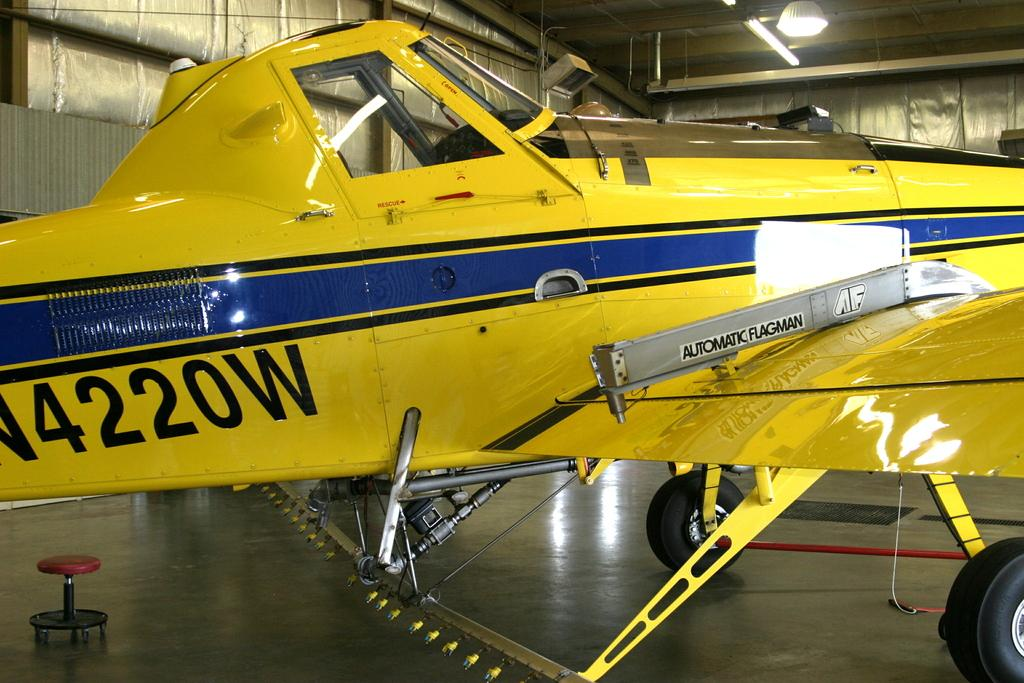<image>
Render a clear and concise summary of the photo. a plane with the numbers 422 on the bottom of it 